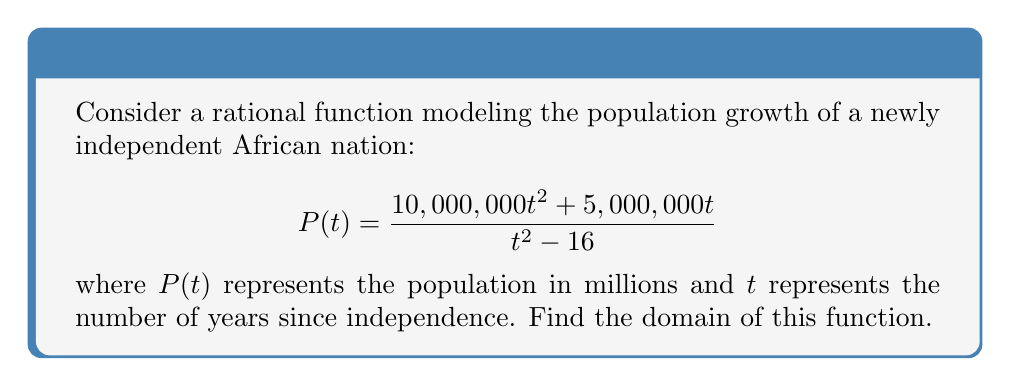Help me with this question. To find the domain of a rational function, we need to consider two things:
1. The denominator cannot be zero.
2. The expression under any even root in the numerator (if present) must be non-negative.

Step 1: Set the denominator equal to zero and solve for t.
$$t^2 - 16 = 0$$
$$t^2 = 16$$
$$t = \pm 4$$

This means that $t$ cannot be equal to 4 or -4.

Step 2: Check if there are any even roots in the numerator.
In this case, there are no even roots in the numerator, so we don't need to consider any additional restrictions.

Step 3: Express the domain in set notation.
The domain is all real numbers except for 4 and -4.

In set notation, this is written as:
$$\{t \in \mathbb{R} : t \neq 4 \text{ and } t \neq -4\}$$

Note: In the context of population growth since independence, negative values of $t$ don't make practical sense. However, mathematically, they are part of the domain of this rational function.
Answer: $\{t \in \mathbb{R} : t \neq 4 \text{ and } t \neq -4\}$ 